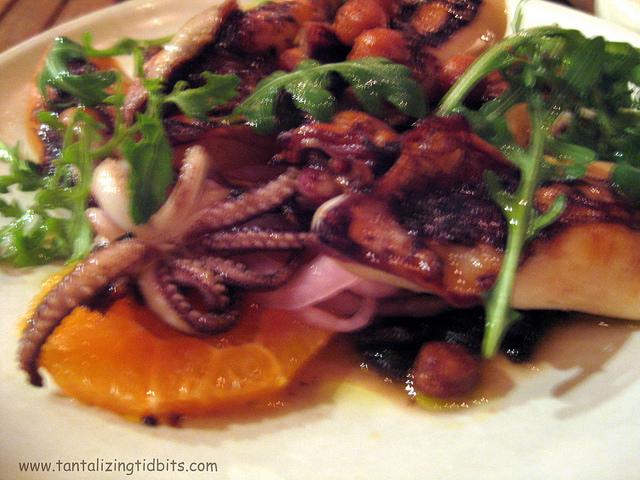What are the green vegetables on the plate called?
Keep it brief. Arugula. What kind of fruit is featured?
Write a very short answer. Orange. Are there green vegetables on the plate?
Answer briefly. Yes. What kind of seafood is on top of the orange?
Short answer required. Octopus. 